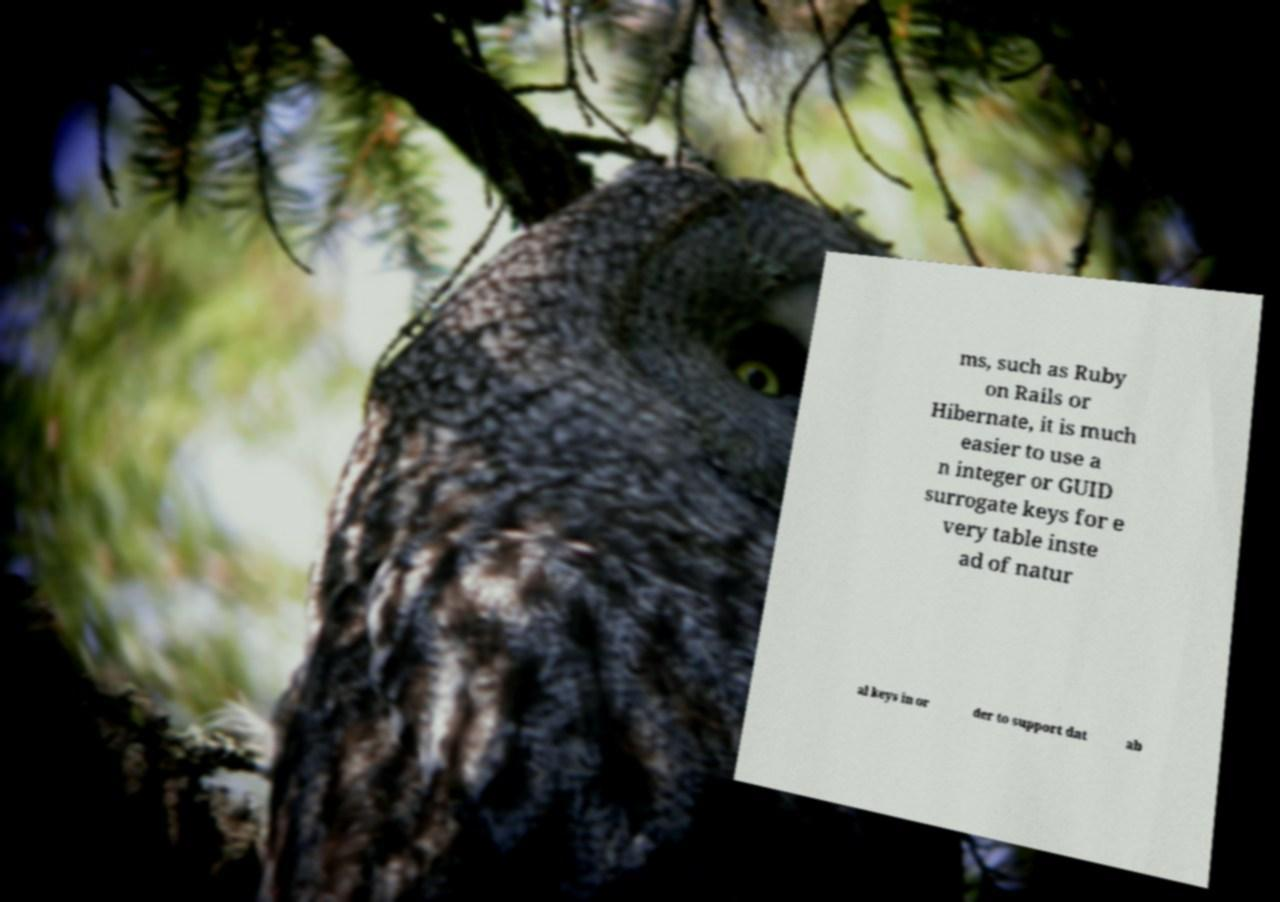Can you accurately transcribe the text from the provided image for me? ms, such as Ruby on Rails or Hibernate, it is much easier to use a n integer or GUID surrogate keys for e very table inste ad of natur al keys in or der to support dat ab 